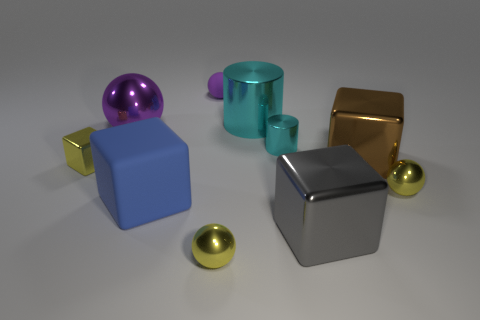Subtract all small yellow blocks. How many blocks are left? 3 Subtract all blue cubes. How many cubes are left? 3 Add 2 big blue rubber blocks. How many big blue rubber blocks exist? 3 Subtract 0 brown spheres. How many objects are left? 10 Subtract all cubes. How many objects are left? 6 Subtract 1 blocks. How many blocks are left? 3 Subtract all yellow balls. Subtract all red cubes. How many balls are left? 2 Subtract all blue blocks. How many red cylinders are left? 0 Subtract all small cyan shiny objects. Subtract all small rubber objects. How many objects are left? 8 Add 3 brown cubes. How many brown cubes are left? 4 